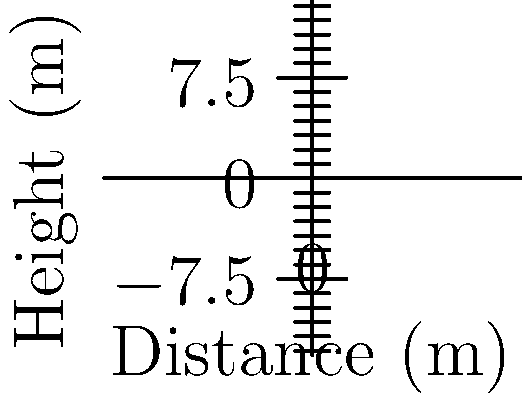As an Australian football fan, you're familiar with different types of footballs. The graph shows the flight paths of three different types of footballs: rugby, soccer, and Aussie Rules. Which football shape would likely travel the farthest distance when kicked with the same initial velocity and angle? To determine which football shape would likely travel the farthest distance, we need to consider the aerodynamics of each ball:

1. Rugby ball (red curve):
   - Elongated shape with pointed ends
   - Higher air resistance due to its larger cross-sectional area
   - More prone to tumbling, which can reduce distance

2. Soccer ball (blue curve):
   - Spherical shape
   - Smoother surface and more uniform air flow
   - Less air resistance compared to rugby ball
   - Can achieve longer distances due to its aerodynamic properties

3. Aussie Rules football (green curve):
   - Oval shape, similar to rugby ball but less elongated
   - Moderate air resistance, between rugby and soccer ball
   - Can maintain a more stable flight path than rugby ball

Comparing the curves:
- The rugby ball's path (red) shows the highest initial climb but drops quickly.
- The soccer ball's path (blue) shows the flattest trajectory.
- The Aussie Rules football's path (green) is between the other two.

The flatter trajectory of the soccer ball indicates less energy lost to vertical motion and air resistance, suggesting it would travel the farthest distance when kicked with the same initial velocity and angle.
Answer: Soccer ball 